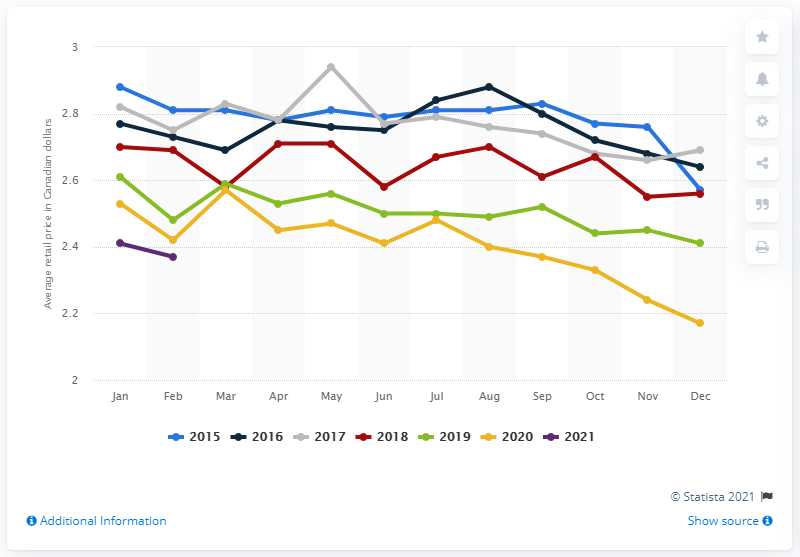Mention a couple of crucial points in this snapshot. In February 2021, the average retail price for two kilograms of white sugar in Canada was 2.37. 